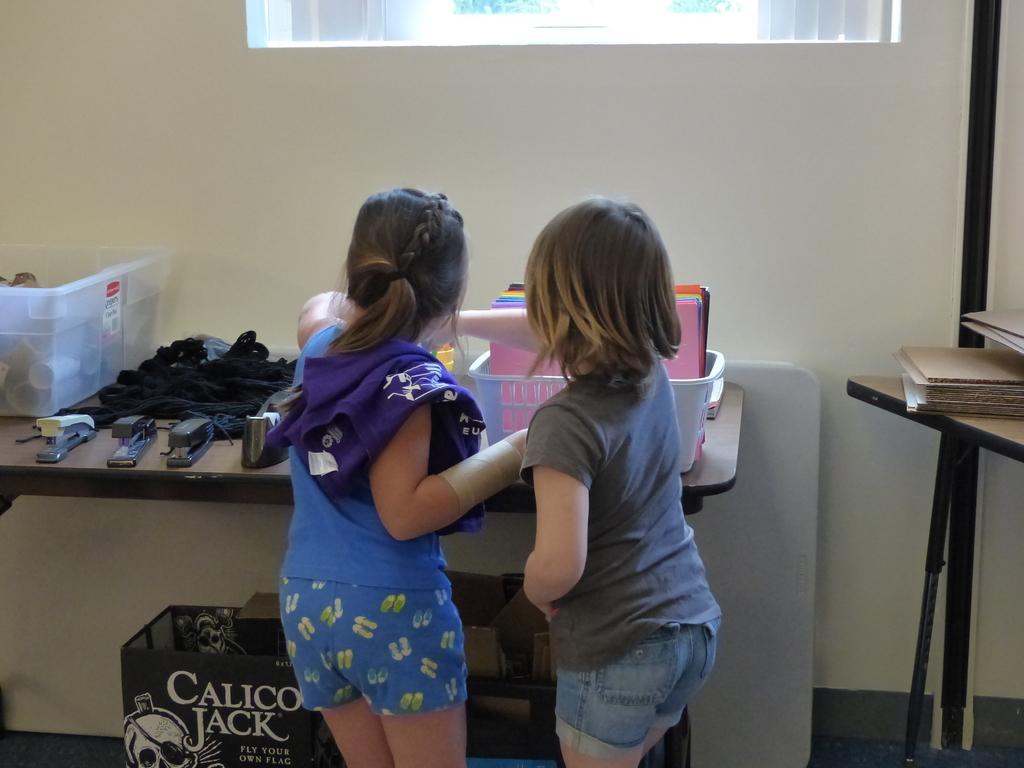What is calico jack catch phrase?
Your answer should be compact. Fly your own flag. 